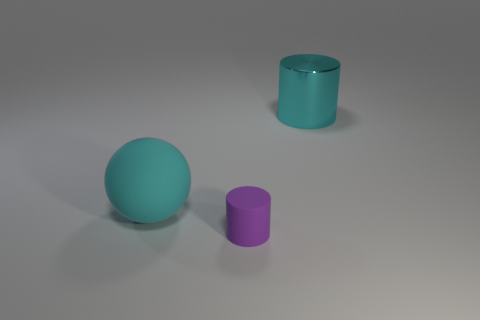Add 2 large brown rubber things. How many objects exist? 5 Subtract all cylinders. How many objects are left? 1 Add 3 big cyan metallic objects. How many big cyan metallic objects exist? 4 Subtract 0 blue cylinders. How many objects are left? 3 Subtract all small purple rubber things. Subtract all big things. How many objects are left? 0 Add 3 cyan cylinders. How many cyan cylinders are left? 4 